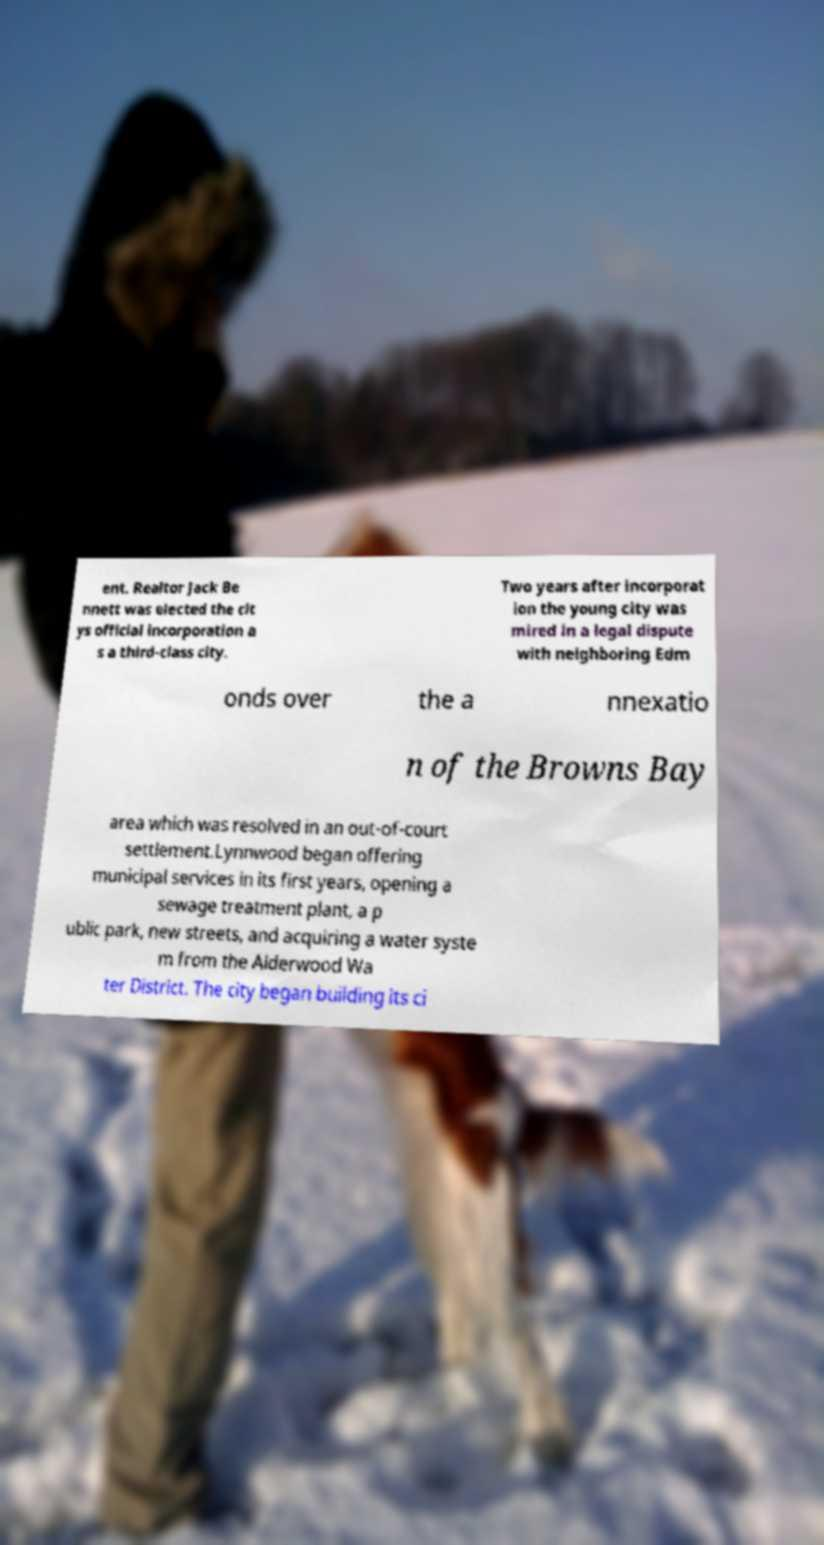Could you assist in decoding the text presented in this image and type it out clearly? ent. Realtor Jack Be nnett was elected the cit ys official incorporation a s a third-class city. Two years after incorporat ion the young city was mired in a legal dispute with neighboring Edm onds over the a nnexatio n of the Browns Bay area which was resolved in an out-of-court settlement.Lynnwood began offering municipal services in its first years, opening a sewage treatment plant, a p ublic park, new streets, and acquiring a water syste m from the Alderwood Wa ter District. The city began building its ci 